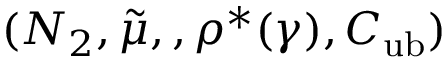Convert formula to latex. <formula><loc_0><loc_0><loc_500><loc_500>( N _ { 2 } , \tilde { \mu } , , \rho ^ { * } ( \gamma ) , C _ { u b } )</formula> 